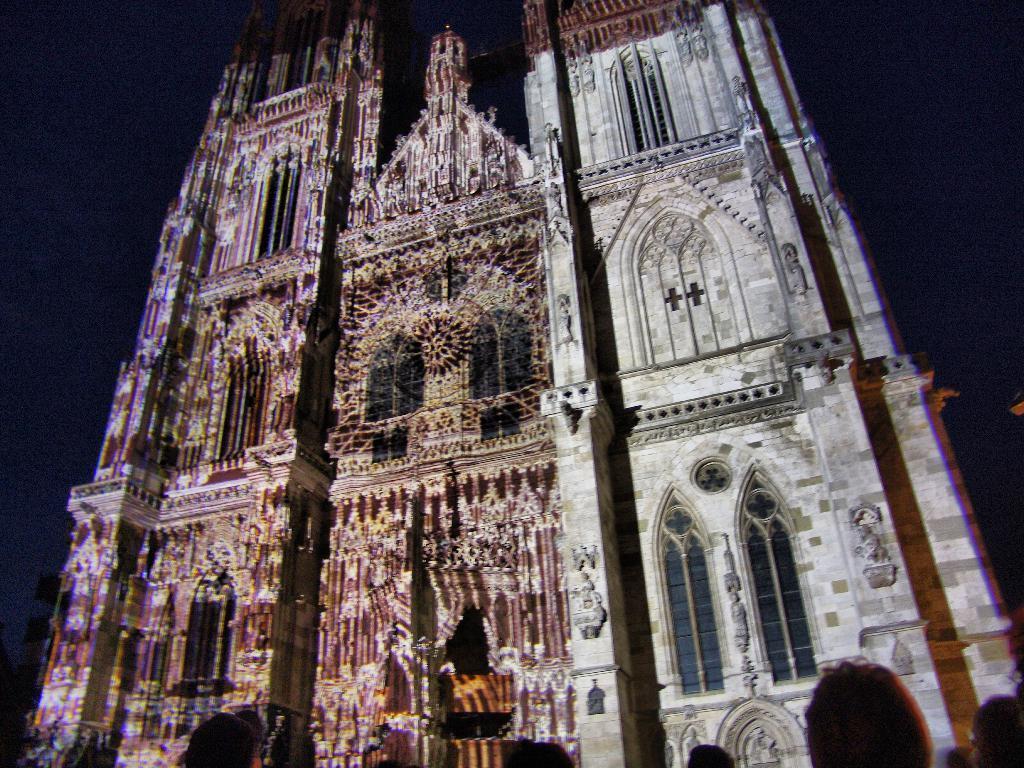How would you summarize this image in a sentence or two? In this image we can see building of a cathedral and there are some lights to the building. 